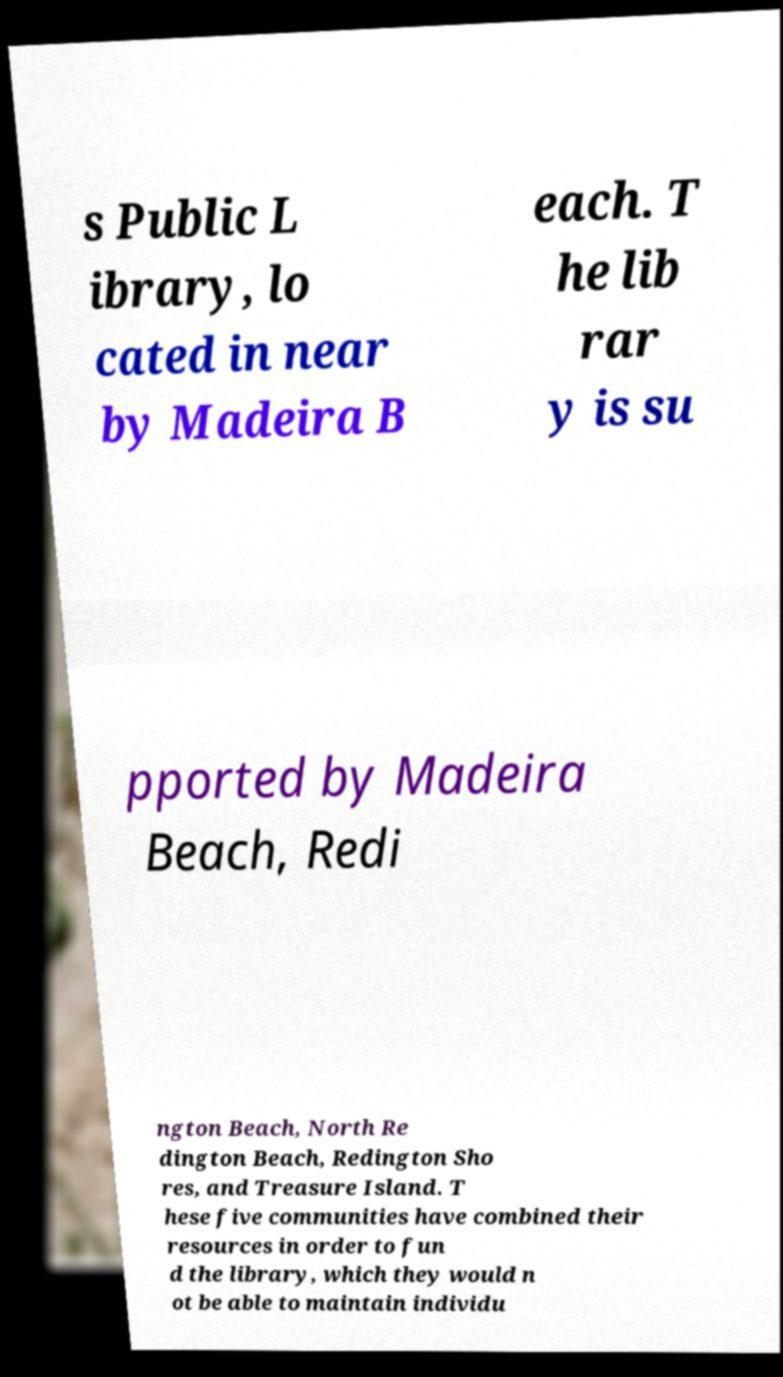There's text embedded in this image that I need extracted. Can you transcribe it verbatim? s Public L ibrary, lo cated in near by Madeira B each. T he lib rar y is su pported by Madeira Beach, Redi ngton Beach, North Re dington Beach, Redington Sho res, and Treasure Island. T hese five communities have combined their resources in order to fun d the library, which they would n ot be able to maintain individu 